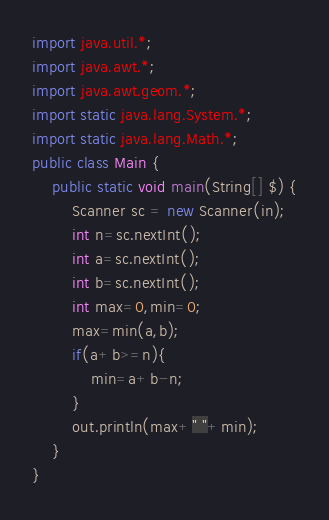Convert code to text. <code><loc_0><loc_0><loc_500><loc_500><_Java_>import java.util.*;
import java.awt.*;
import java.awt.geom.*;
import static java.lang.System.*;
import static java.lang.Math.*;
public class Main {
    public static void main(String[] $) {
        Scanner sc = new Scanner(in);
        int n=sc.nextInt();
        int a=sc.nextInt();
        int b=sc.nextInt();
        int max=0,min=0;
        max=min(a,b);
        if(a+b>=n){
            min=a+b-n;
        }
        out.println(max+" "+min);
    }
}</code> 